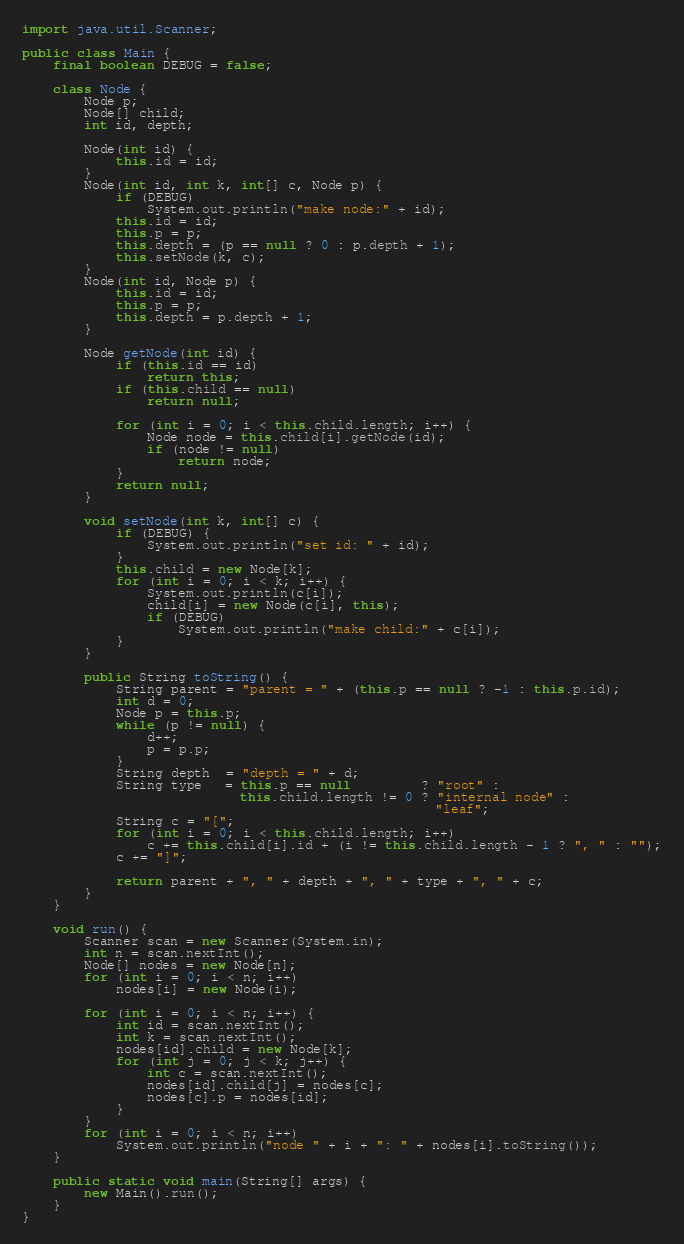<code> <loc_0><loc_0><loc_500><loc_500><_Java_>import java.util.Scanner;

public class Main {
	final boolean DEBUG = false;

	class Node {
		Node p;
		Node[] child;
		int id, depth;
		
		Node(int id) {
			this.id = id;
		}
		Node(int id, int k, int[] c, Node p) {
			if (DEBUG)
				System.out.println("make node:" + id);
			this.id = id;
			this.p = p;
			this.depth = (p == null ? 0 : p.depth + 1);
			this.setNode(k, c);
		}
		Node(int id, Node p) {
			this.id = id;
			this.p = p;
			this.depth = p.depth + 1;
		}
		
		Node getNode(int id) {
			if (this.id == id)
				return this;
			if (this.child == null)
				return null;

			for (int i = 0; i < this.child.length; i++) {
				Node node = this.child[i].getNode(id);
				if (node != null)
					return node;
			}
			return null;
		}

		void setNode(int k, int[] c) {
			if (DEBUG) {
				System.out.println("set id: " + id);
			}
			this.child = new Node[k];
			for (int i = 0; i < k; i++) {
				System.out.println(c[i]);
				child[i] = new Node(c[i], this);
				if (DEBUG)
					System.out.println("make child:" + c[i]);
			}
		}
		
		public String toString() {
			String parent = "parent = " + (this.p == null ? -1 : this.p.id);
			int d = 0;
			Node p = this.p;
			while (p != null) {
				d++;
				p = p.p;
			}
			String depth  = "depth = " + d;
			String type   = this.p == null         ? "root" :
							this.child.length != 0 ? "internal node" :
													 "leaf";
			String c = "[";
			for (int i = 0; i < this.child.length; i++)
				c += this.child[i].id + (i != this.child.length - 1 ? ", " : "");
			c += "]";

			return parent + ", " + depth + ", " + type + ", " + c;
		}
	}
	
	void run() {
		Scanner scan = new Scanner(System.in);
		int n = scan.nextInt();
		Node[] nodes = new Node[n];
		for (int i = 0; i < n; i++)
			nodes[i] = new Node(i);

		for (int i = 0; i < n; i++) {
			int id = scan.nextInt();
			int k = scan.nextInt();
			nodes[id].child = new Node[k];
			for (int j = 0; j < k; j++) {
				int c = scan.nextInt();
				nodes[id].child[j] = nodes[c];
				nodes[c].p = nodes[id];
			}
		}
		for (int i = 0; i < n; i++)
			System.out.println("node " + i + ": " + nodes[i].toString());
	}

	public static void main(String[] args) {
		new Main().run();
	}
}

</code> 